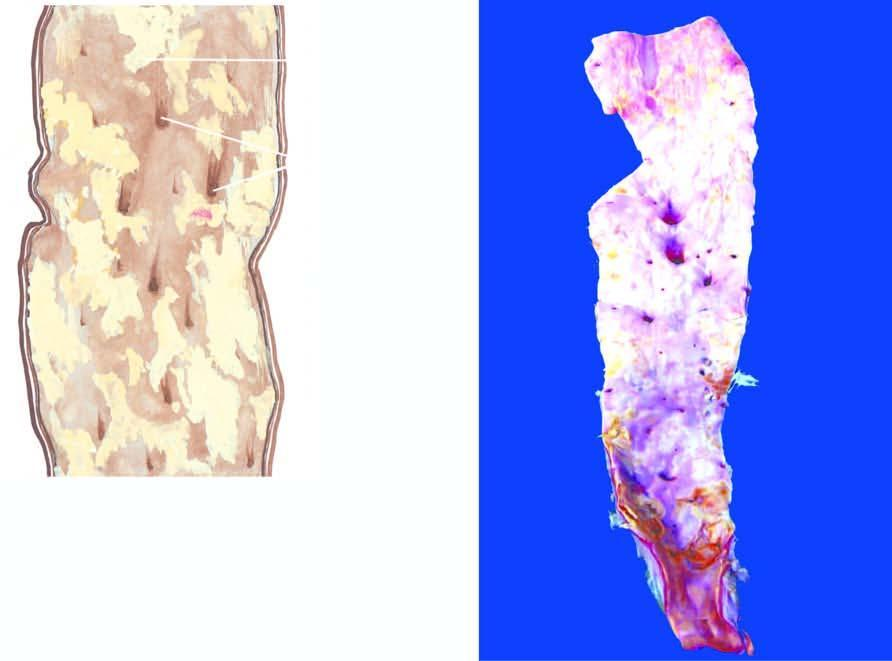re orifices of some of the branches coming out of the wall narrowed by the atherosclerotic process?
Answer the question using a single word or phrase. Yes 